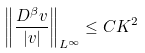Convert formula to latex. <formula><loc_0><loc_0><loc_500><loc_500>\left \| \frac { D ^ { \beta } v } { | v | } \right \| _ { L ^ { \infty } } \leq C K ^ { 2 }</formula> 